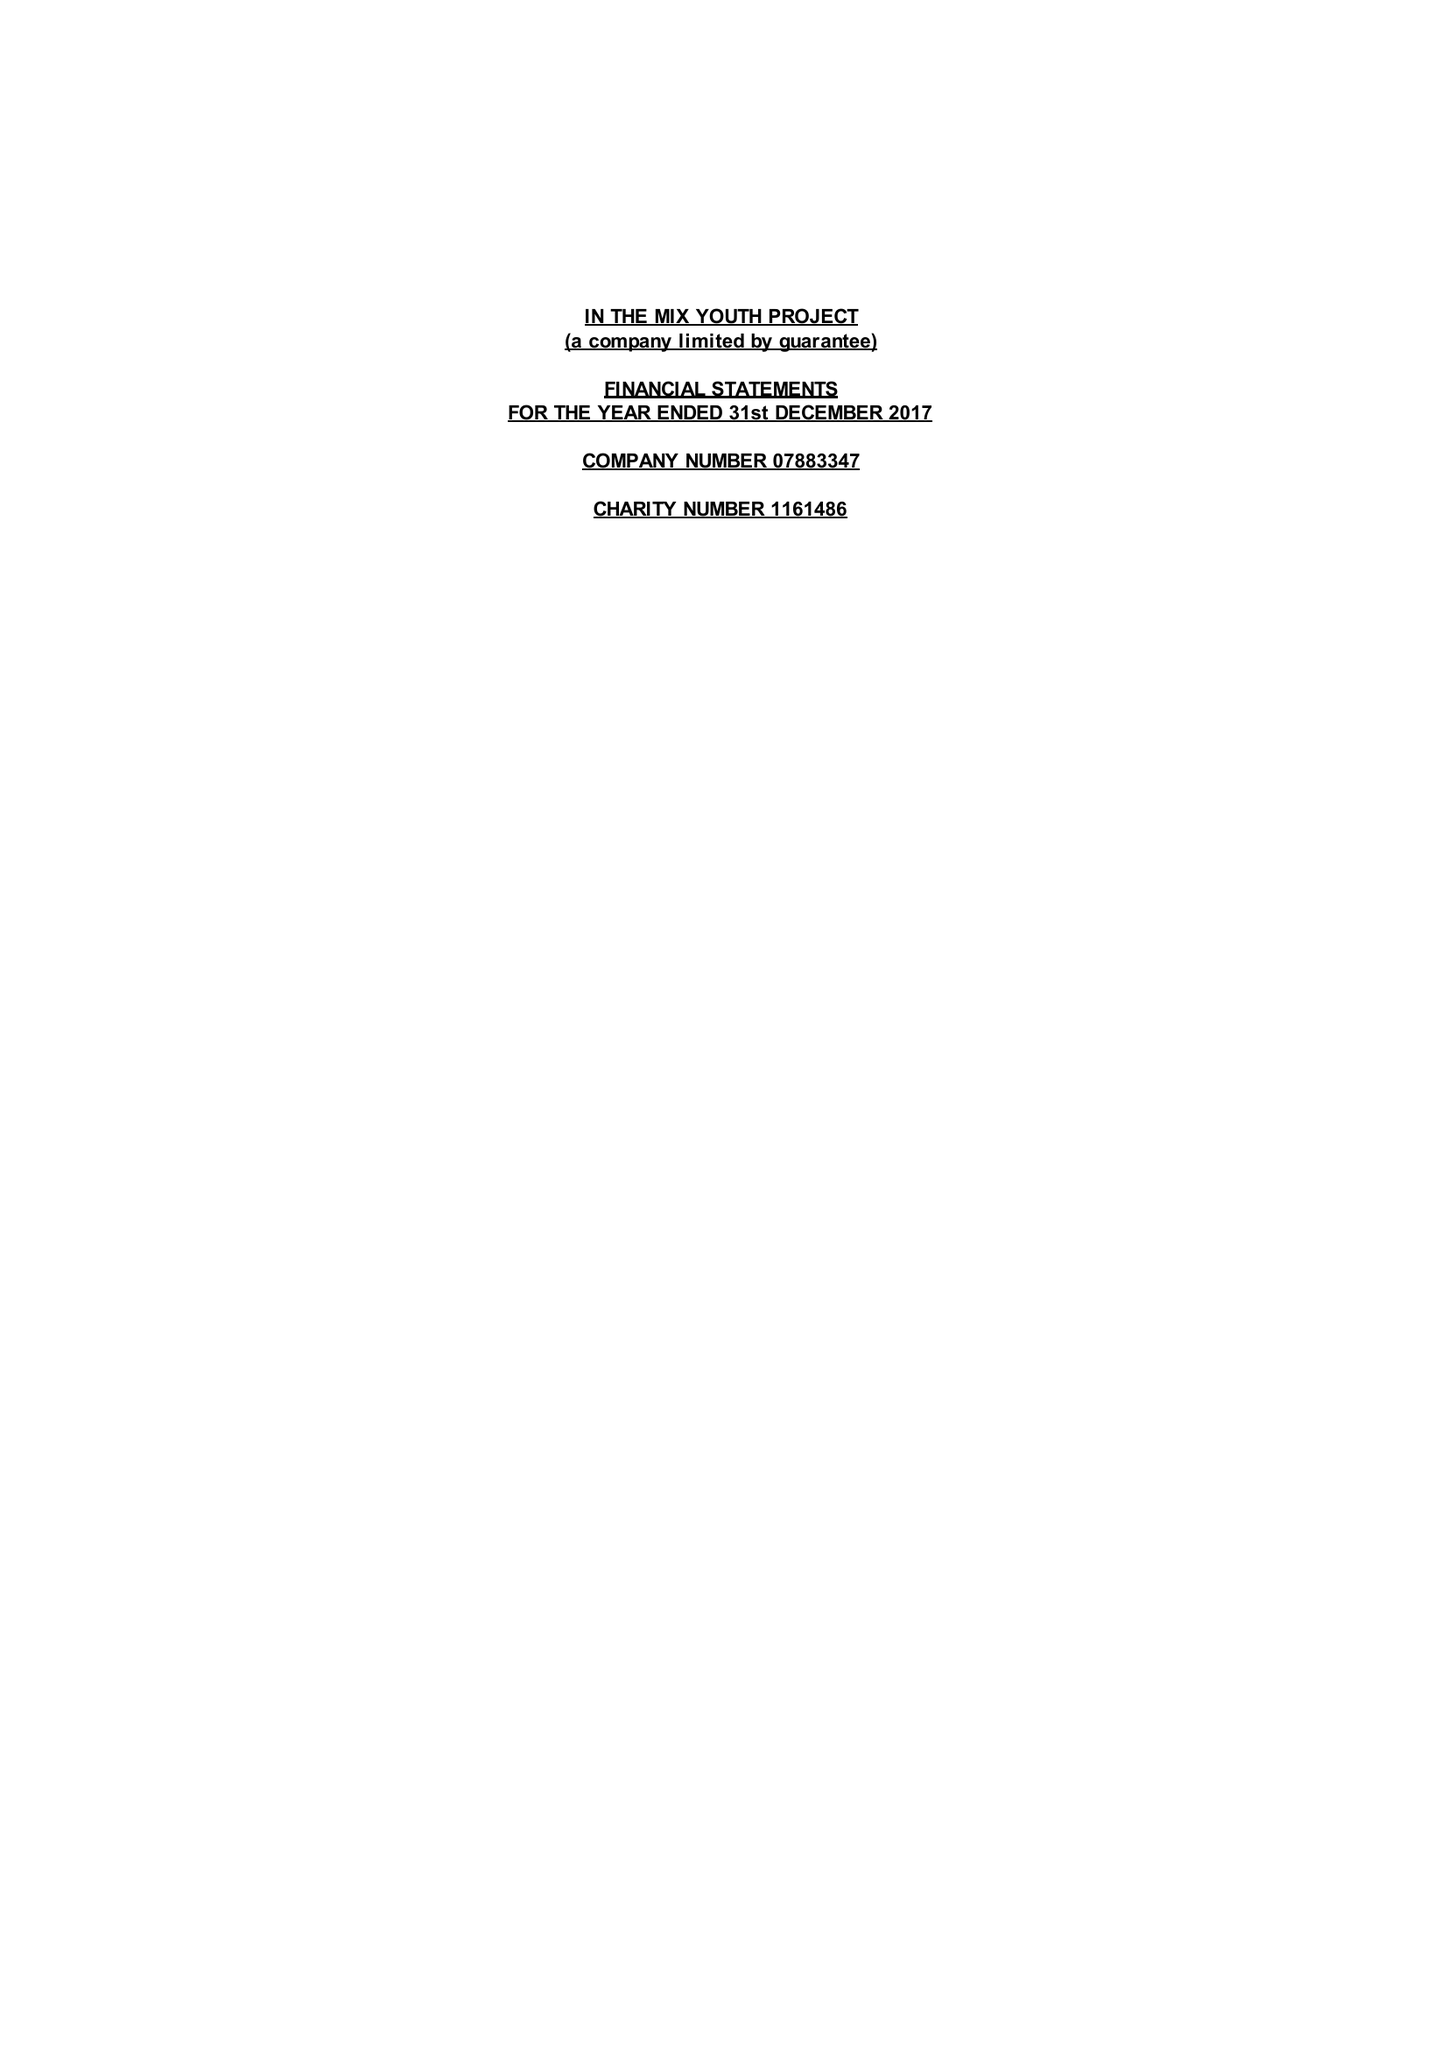What is the value for the charity_name?
Answer the question using a single word or phrase. In The Mix Youth Project 